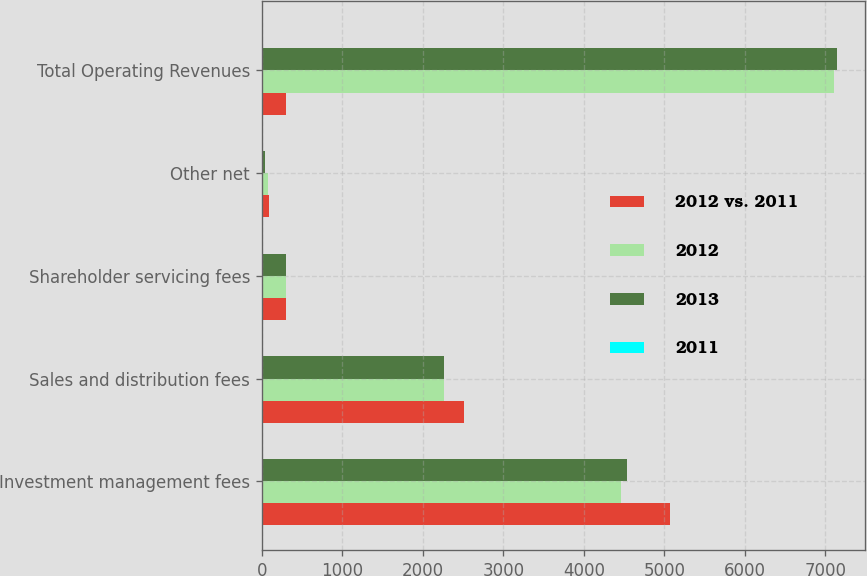Convert chart. <chart><loc_0><loc_0><loc_500><loc_500><stacked_bar_chart><ecel><fcel>Investment management fees<fcel>Sales and distribution fees<fcel>Shareholder servicing fees<fcel>Other net<fcel>Total Operating Revenues<nl><fcel>2012 vs. 2011<fcel>5071.4<fcel>2516<fcel>303.7<fcel>93.9<fcel>302.5<nl><fcel>2012<fcel>4458.7<fcel>2259.3<fcel>302.5<fcel>80.5<fcel>7101<nl><fcel>2013<fcel>4531.4<fcel>2263.5<fcel>300.8<fcel>44.3<fcel>7140<nl><fcel>2011<fcel>14<fcel>11<fcel>0<fcel>17<fcel>12<nl></chart> 